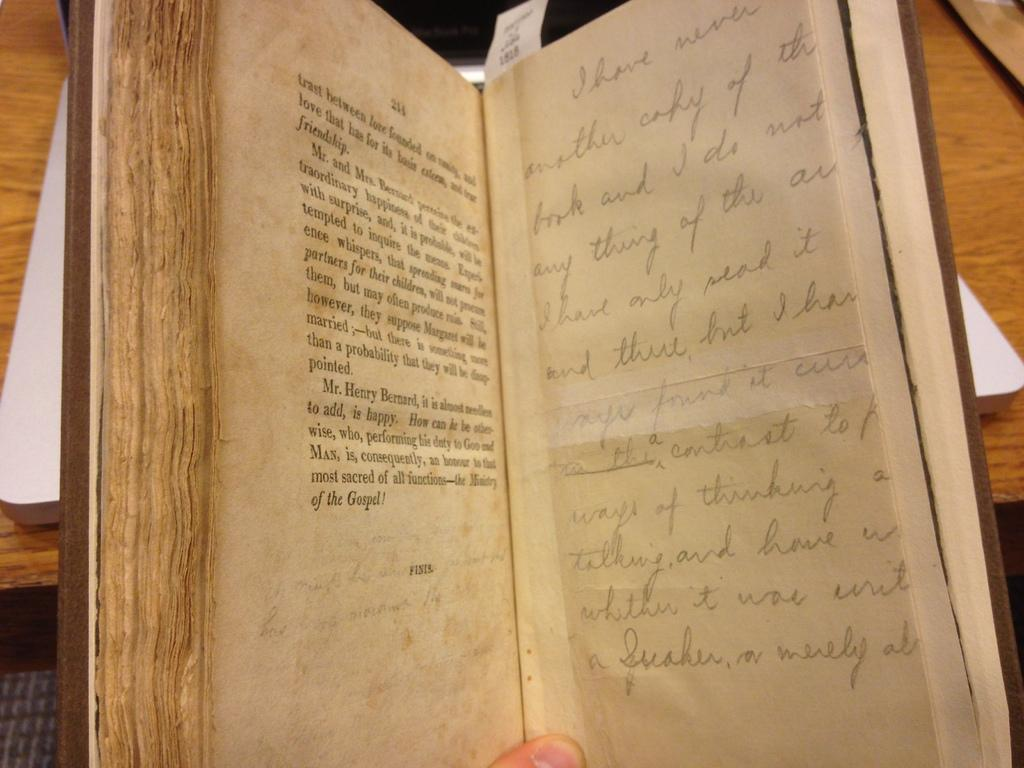<image>
Create a compact narrative representing the image presented. The book is opened to the pages of 211 and 212 